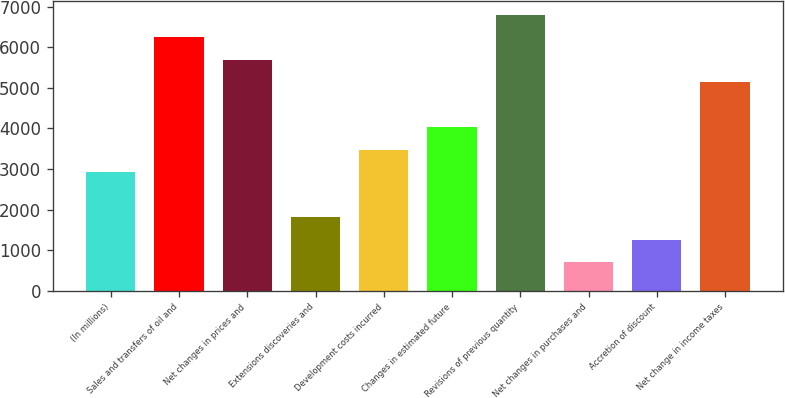Convert chart. <chart><loc_0><loc_0><loc_500><loc_500><bar_chart><fcel>(In millions)<fcel>Sales and transfers of oil and<fcel>Net changes in prices and<fcel>Extensions discoveries and<fcel>Development costs incurred<fcel>Changes in estimated future<fcel>Revisions of previous quantity<fcel>Net changes in purchases and<fcel>Accretion of discount<fcel>Net change in income taxes<nl><fcel>2920<fcel>6245.2<fcel>5691<fcel>1811.6<fcel>3474.2<fcel>4028.4<fcel>6799.4<fcel>703.2<fcel>1257.4<fcel>5136.8<nl></chart> 